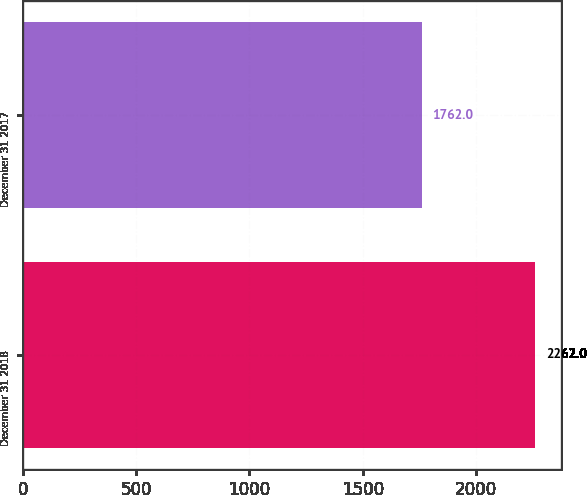Convert chart to OTSL. <chart><loc_0><loc_0><loc_500><loc_500><bar_chart><fcel>December 31 2018<fcel>December 31 2017<nl><fcel>2262<fcel>1762<nl></chart> 